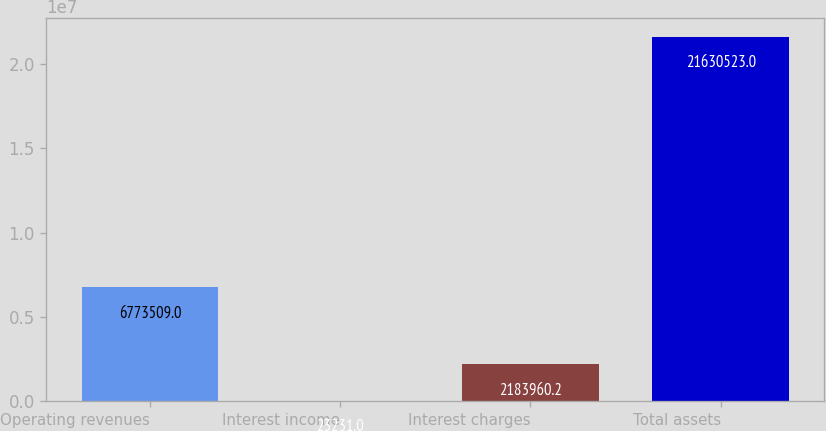<chart> <loc_0><loc_0><loc_500><loc_500><bar_chart><fcel>Operating revenues<fcel>Interest income<fcel>Interest charges<fcel>Total assets<nl><fcel>6.77351e+06<fcel>23231<fcel>2.18396e+06<fcel>2.16305e+07<nl></chart> 